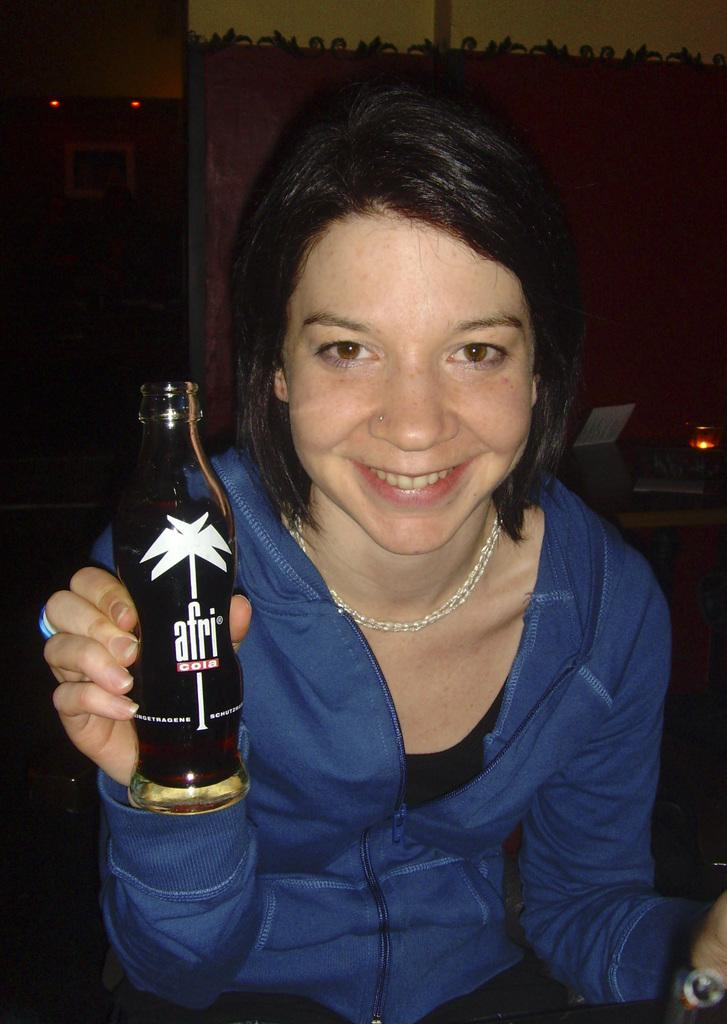Who is present in the image? There is a woman in the image. What is the woman holding in the image? The woman is holding a bottle. What is the woman's emotional state in the image? The woman is laughing in the image. Where is the woman eating her lunch in the image? There is no mention of lunch or a lunchroom in the image; the woman is holding a bottle and laughing. 